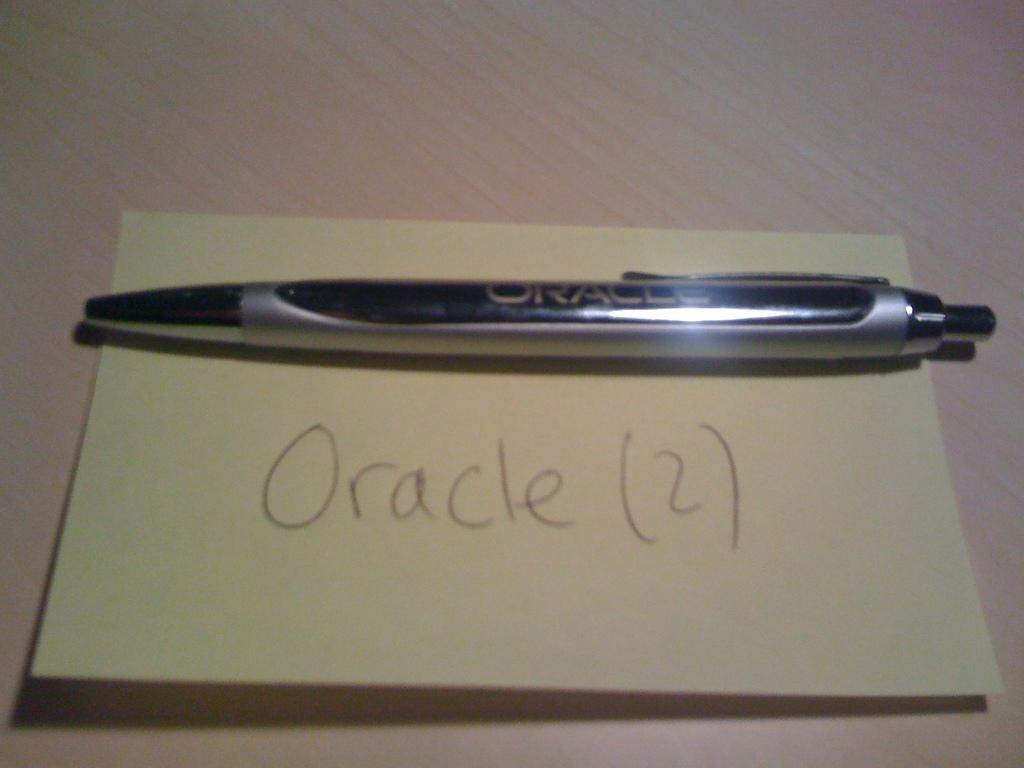Could you give a brief overview of what you see in this image? In this image, we can see a pen on the paper contains some written text. 